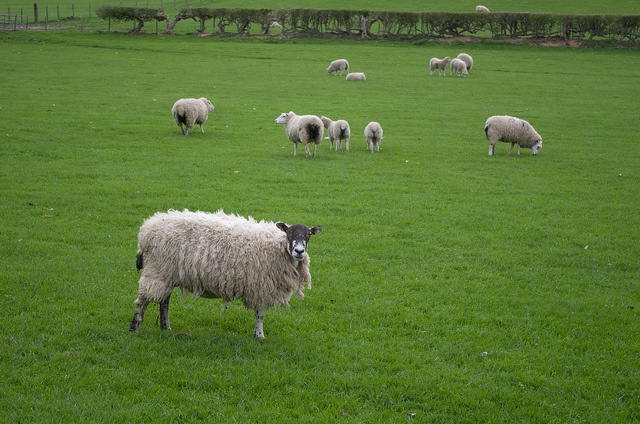Describe the objects in this image and their specific colors. I can see sheep in darkgreen, gray, darkgray, and lightgray tones, sheep in darkgreen, gray, darkgray, and black tones, sheep in darkgreen, darkgray, gray, black, and lightgray tones, sheep in darkgreen, darkgray, gray, black, and lightgray tones, and sheep in darkgreen, darkgray, gray, and lightgray tones in this image. 